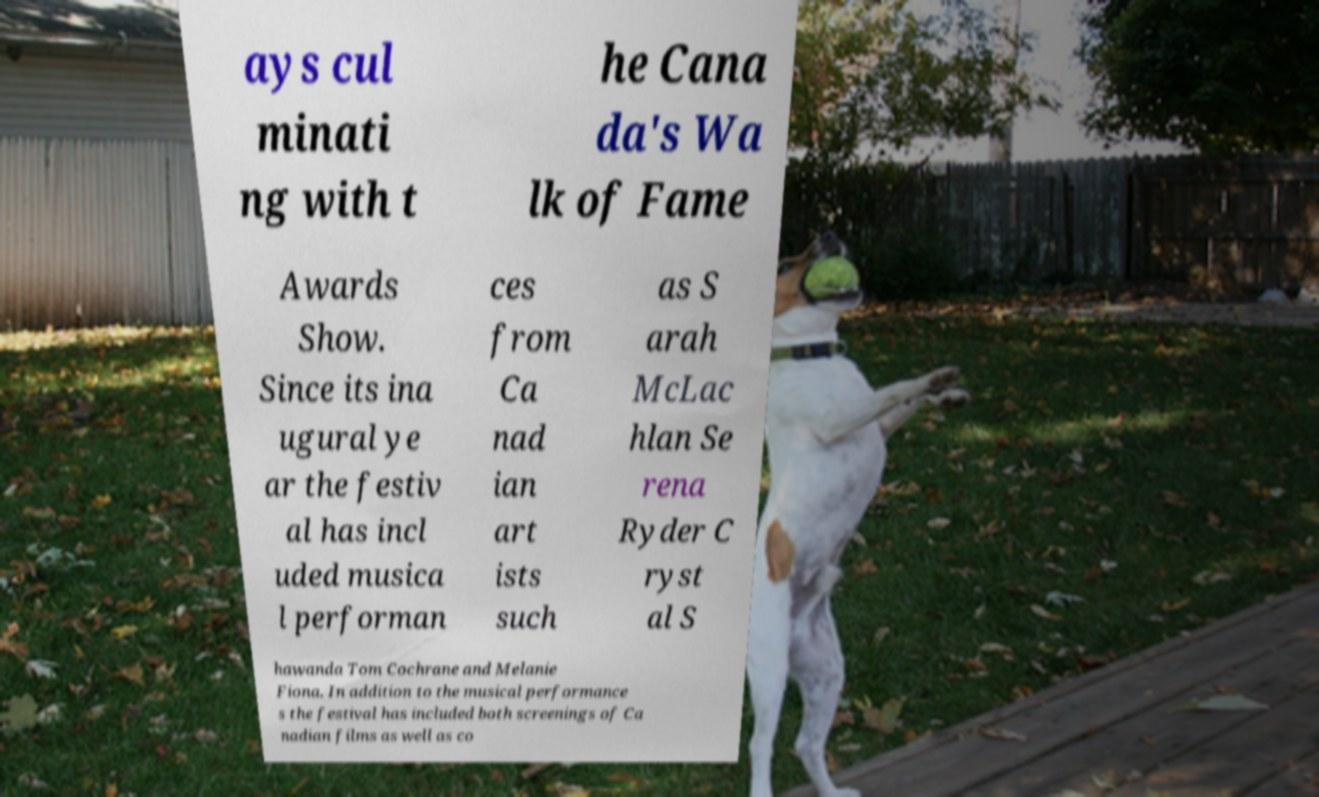What messages or text are displayed in this image? I need them in a readable, typed format. ays cul minati ng with t he Cana da's Wa lk of Fame Awards Show. Since its ina ugural ye ar the festiv al has incl uded musica l performan ces from Ca nad ian art ists such as S arah McLac hlan Se rena Ryder C ryst al S hawanda Tom Cochrane and Melanie Fiona. In addition to the musical performance s the festival has included both screenings of Ca nadian films as well as co 